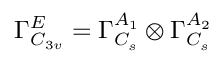Convert formula to latex. <formula><loc_0><loc_0><loc_500><loc_500>\Gamma _ { C _ { 3 v } } ^ { E } = \Gamma _ { C _ { s } } ^ { A _ { 1 } } \otimes \Gamma _ { C _ { s } } ^ { A _ { 2 } }</formula> 